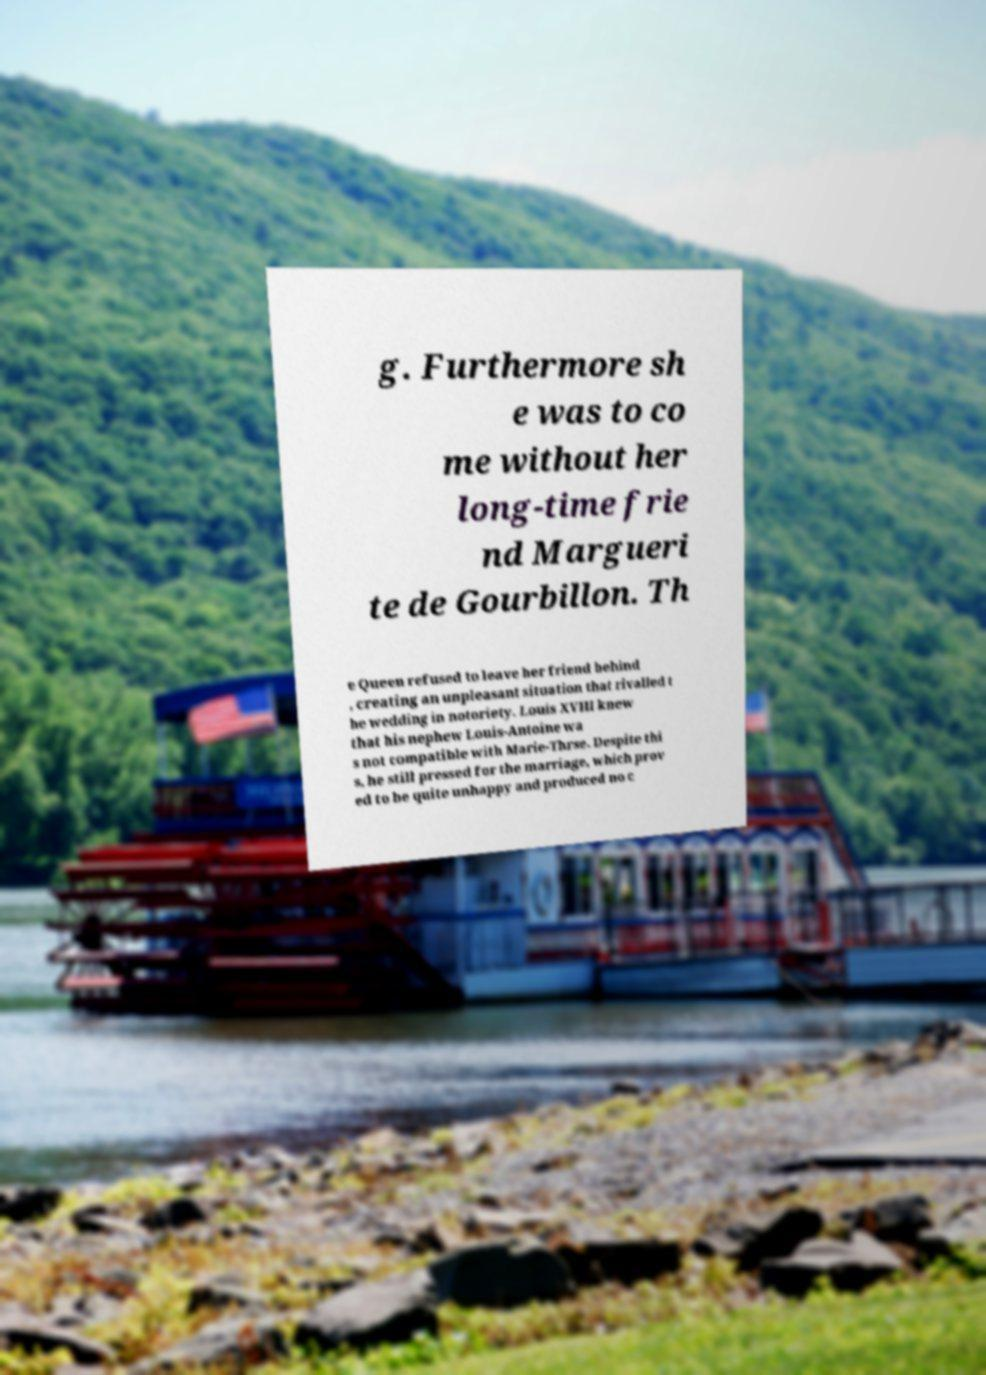Could you extract and type out the text from this image? g. Furthermore sh e was to co me without her long-time frie nd Margueri te de Gourbillon. Th e Queen refused to leave her friend behind , creating an unpleasant situation that rivalled t he wedding in notoriety. Louis XVIII knew that his nephew Louis-Antoine wa s not compatible with Marie-Thrse. Despite thi s, he still pressed for the marriage, which prov ed to be quite unhappy and produced no c 